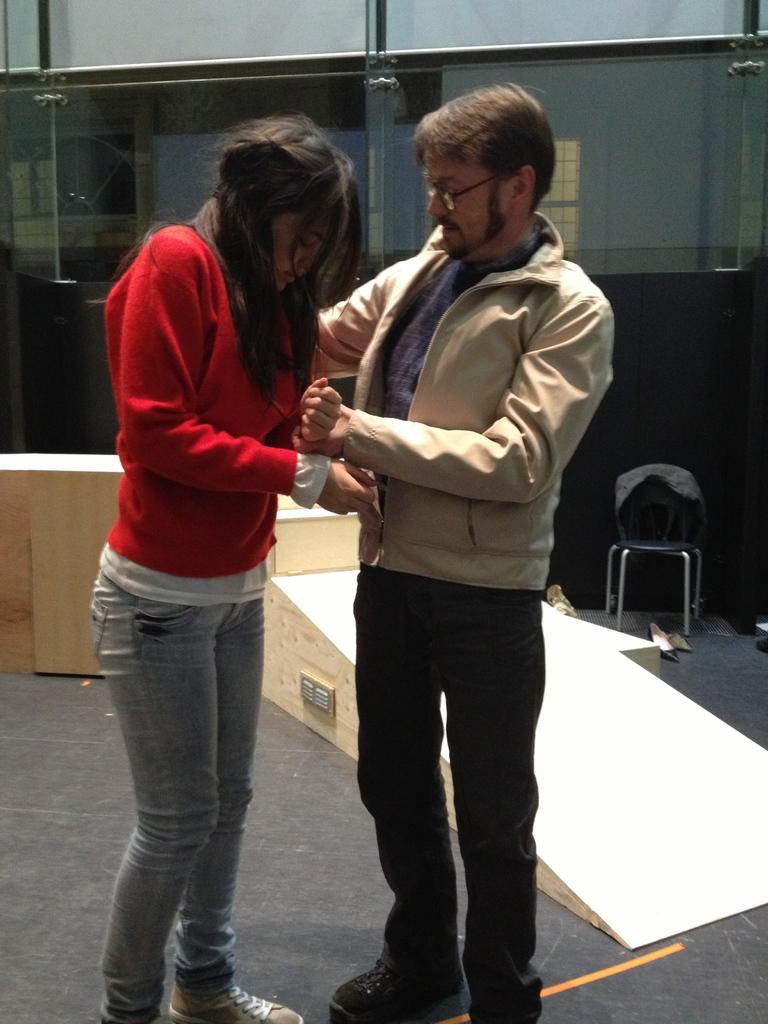Can you describe this image briefly? This is the picture of a place where we have a lady in red top and a guy who is wearing jacket and behind there is something. 